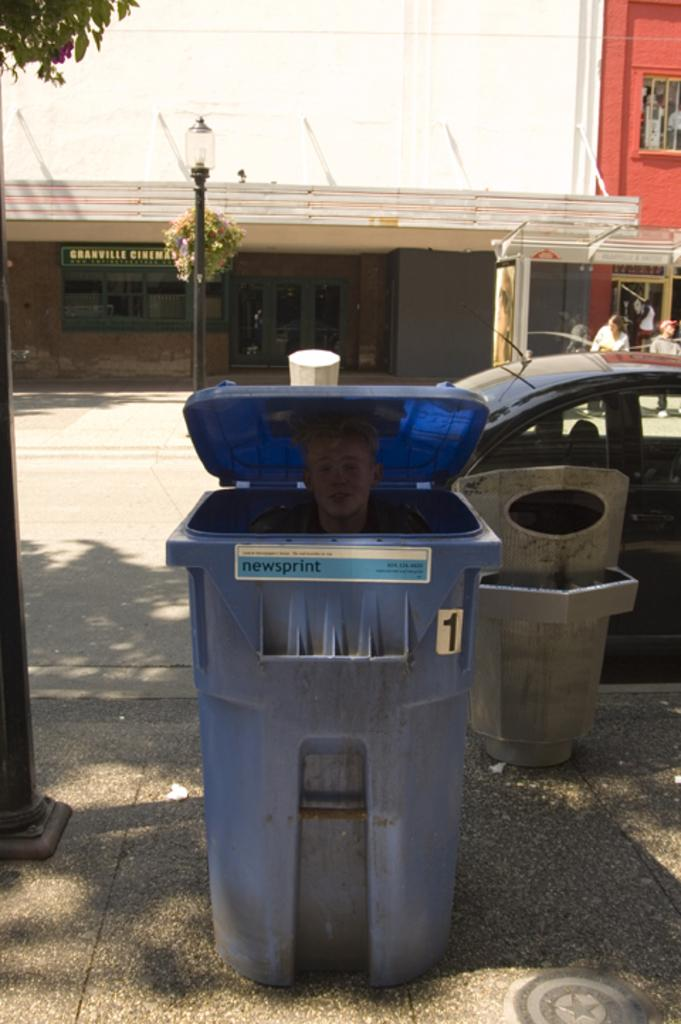<image>
Render a clear and concise summary of the photo. A blue trash can with a person in it says newsprint on the front. 